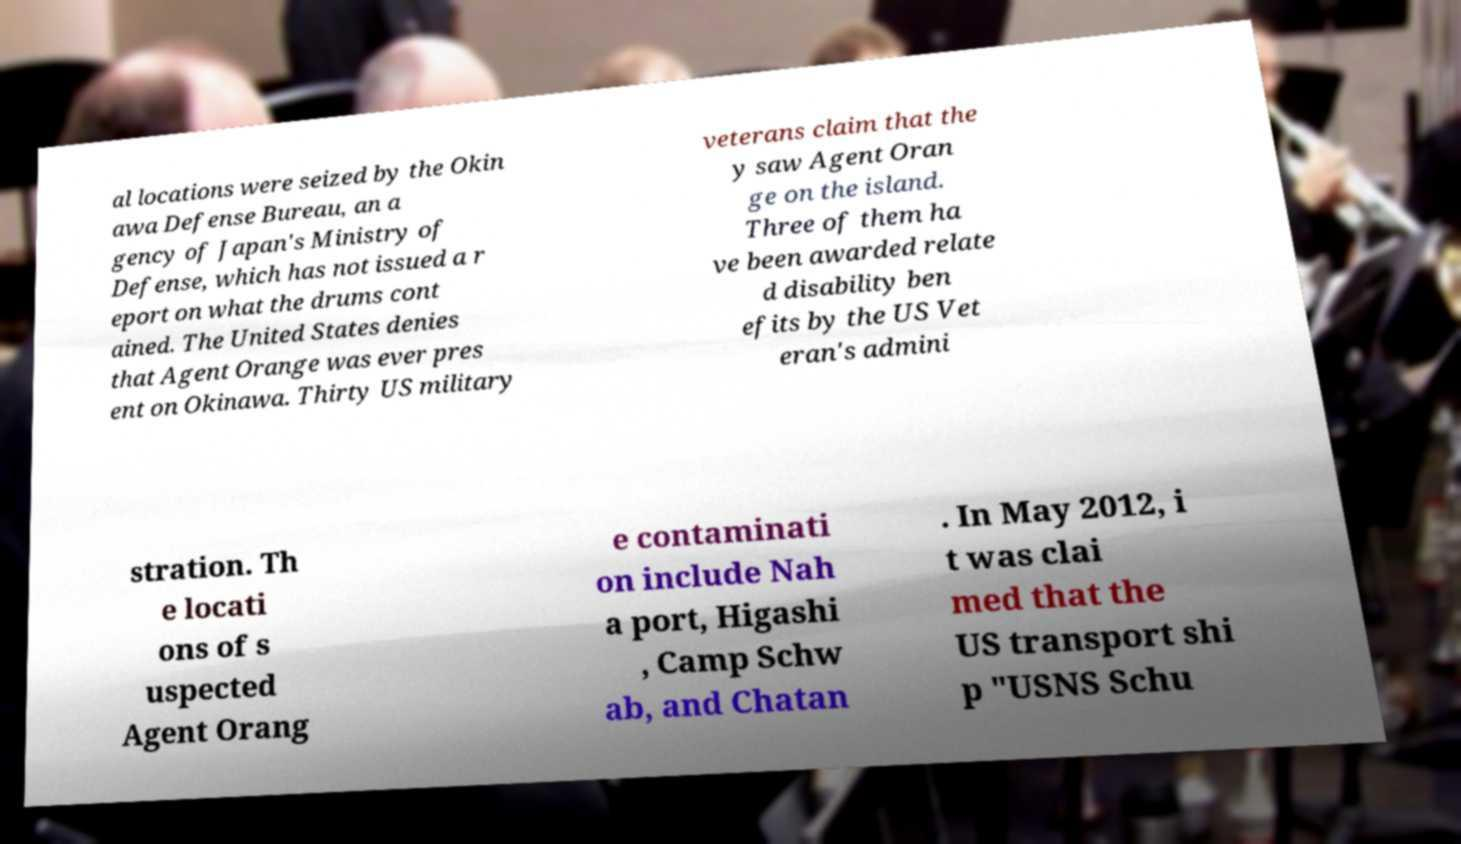Can you accurately transcribe the text from the provided image for me? al locations were seized by the Okin awa Defense Bureau, an a gency of Japan's Ministry of Defense, which has not issued a r eport on what the drums cont ained. The United States denies that Agent Orange was ever pres ent on Okinawa. Thirty US military veterans claim that the y saw Agent Oran ge on the island. Three of them ha ve been awarded relate d disability ben efits by the US Vet eran's admini stration. Th e locati ons of s uspected Agent Orang e contaminati on include Nah a port, Higashi , Camp Schw ab, and Chatan . In May 2012, i t was clai med that the US transport shi p "USNS Schu 